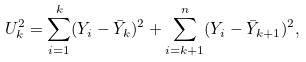<formula> <loc_0><loc_0><loc_500><loc_500>U _ { k } ^ { 2 } = \sum _ { i = 1 } ^ { k } ( Y _ { i } - \bar { Y } _ { k } ) ^ { 2 } + \sum _ { i = k + 1 } ^ { n } ( Y _ { i } - \bar { Y } _ { k + 1 } ) ^ { 2 } ,</formula> 